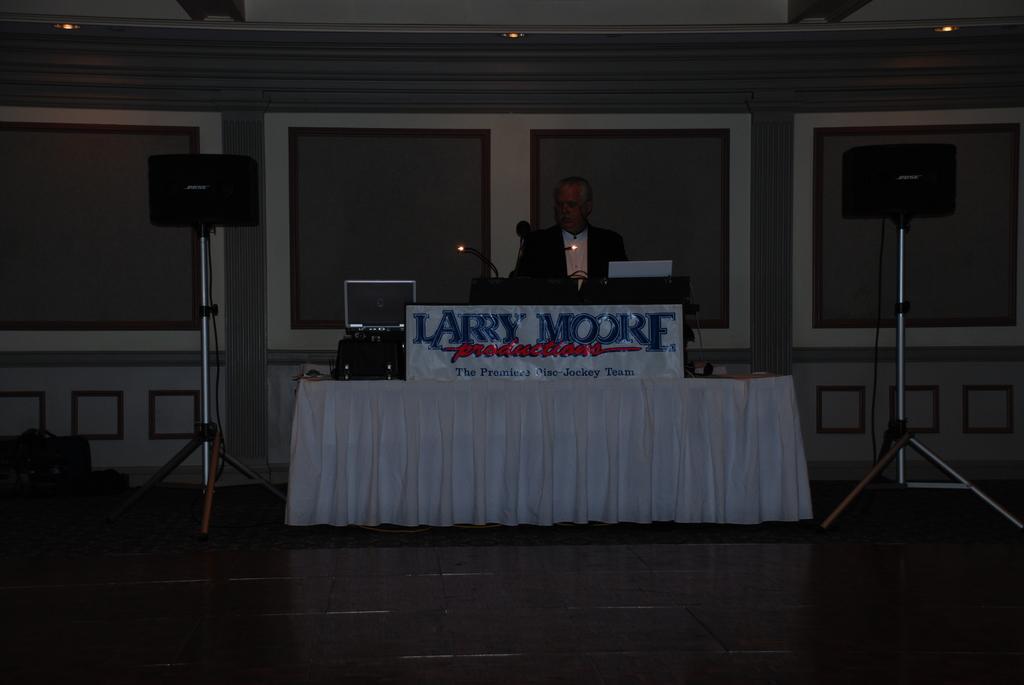Please provide a concise description of this image. In the middle of this image there is a table which is covered with a white color cloth. On the table, I can see a monitor, a board and some other objects. Behind the table there is a podium and behind this a man is standing. On the both sides of the table, I can see two metal stands. At the top of these metal stands two speakers are attached. At the bottom, I can see the floor. In the background there is a wall. On the left side, I can see few objects on the floor. 